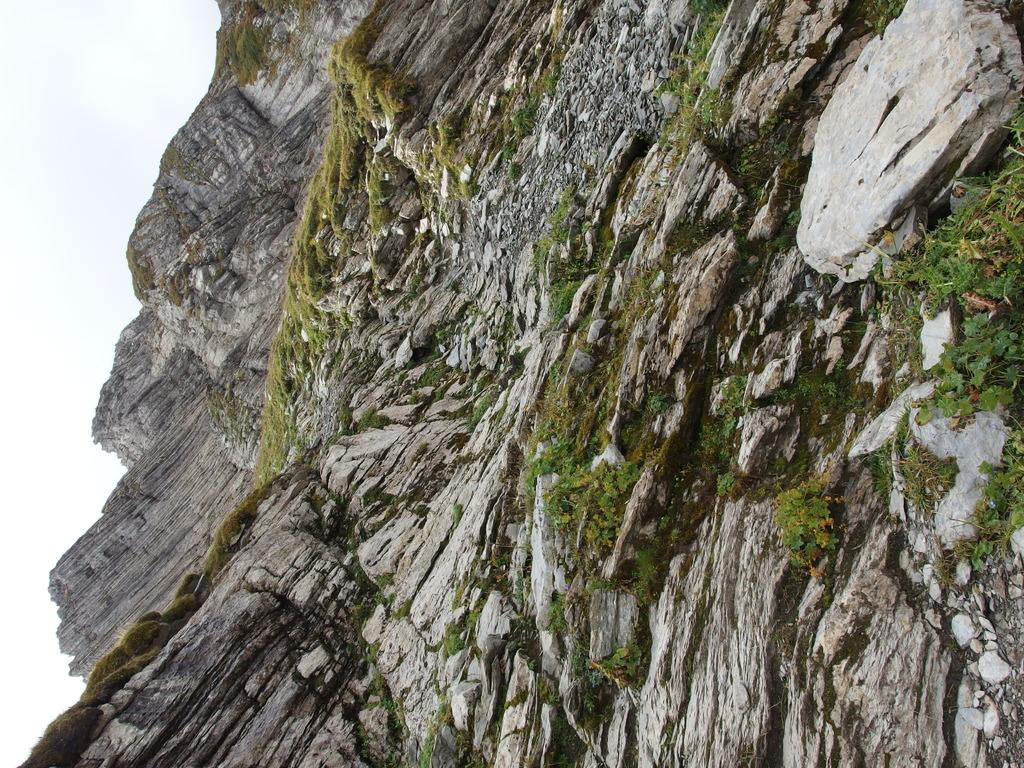What type of natural formation is in the image? There is a rock cliff in the image. What type of vegetation is present on the rock cliff? There is grass and plants on the rock cliff. What part of the sky is visible in the image? The sky is visible on the left side of the image. How many snakes can be seen slithering on the rock cliff in the image? There are no snakes present in the image; it features a rock cliff with grass and plants. What type of clouds can be seen in the sky on the left side of the image? There is no mention of clouds in the image; only the sky is visible on the left side. 